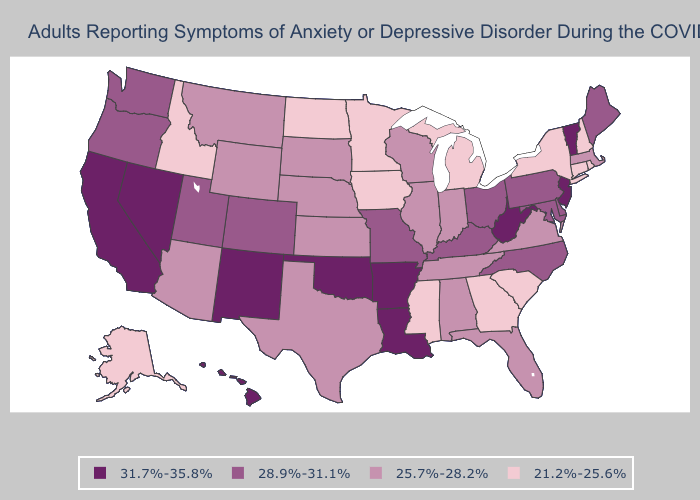Does New Mexico have a lower value than South Carolina?
Be succinct. No. Does Montana have the lowest value in the West?
Give a very brief answer. No. Among the states that border Kentucky , which have the lowest value?
Quick response, please. Illinois, Indiana, Tennessee, Virginia. Among the states that border Arizona , which have the lowest value?
Concise answer only. Colorado, Utah. Does the map have missing data?
Answer briefly. No. Does the map have missing data?
Be succinct. No. Does Arizona have the same value as Kentucky?
Quick response, please. No. What is the highest value in the USA?
Keep it brief. 31.7%-35.8%. What is the value of Oklahoma?
Answer briefly. 31.7%-35.8%. Name the states that have a value in the range 31.7%-35.8%?
Write a very short answer. Arkansas, California, Hawaii, Louisiana, Nevada, New Jersey, New Mexico, Oklahoma, Vermont, West Virginia. Among the states that border Texas , which have the highest value?
Concise answer only. Arkansas, Louisiana, New Mexico, Oklahoma. What is the value of West Virginia?
Write a very short answer. 31.7%-35.8%. Which states have the lowest value in the Northeast?
Give a very brief answer. Connecticut, New Hampshire, New York, Rhode Island. Is the legend a continuous bar?
Short answer required. No. 